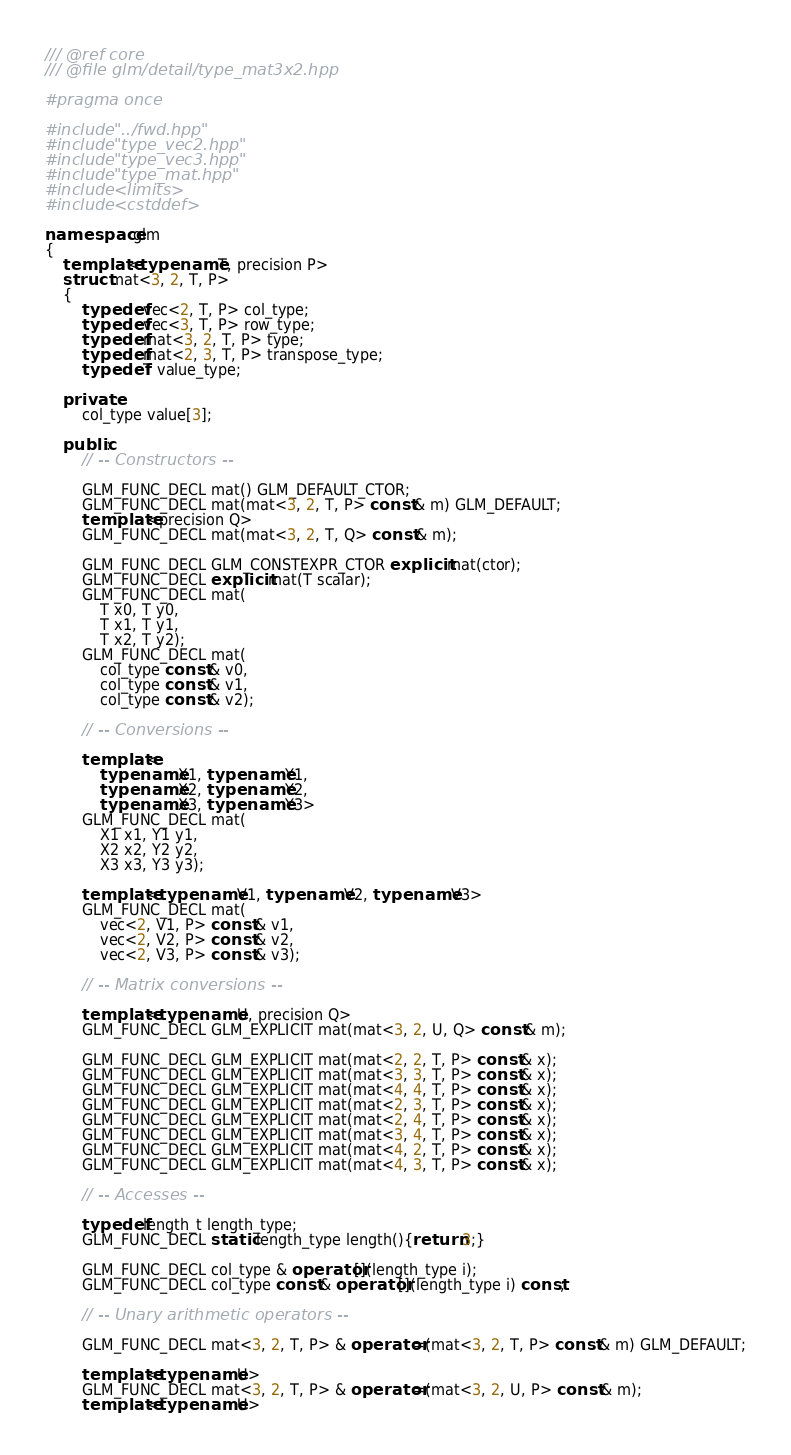<code> <loc_0><loc_0><loc_500><loc_500><_C++_>/// @ref core
/// @file glm/detail/type_mat3x2.hpp

#pragma once

#include "../fwd.hpp"
#include "type_vec2.hpp"
#include "type_vec3.hpp"
#include "type_mat.hpp"
#include <limits>
#include <cstddef>

namespace glm
{
	template<typename T, precision P>
	struct mat<3, 2, T, P>
	{
		typedef vec<2, T, P> col_type;
		typedef vec<3, T, P> row_type;
		typedef mat<3, 2, T, P> type;
		typedef mat<2, 3, T, P> transpose_type;
		typedef T value_type;

	private:
		col_type value[3];

	public:
		// -- Constructors --

		GLM_FUNC_DECL mat() GLM_DEFAULT_CTOR;
		GLM_FUNC_DECL mat(mat<3, 2, T, P> const & m) GLM_DEFAULT;
		template<precision Q>
		GLM_FUNC_DECL mat(mat<3, 2, T, Q> const & m);

		GLM_FUNC_DECL GLM_CONSTEXPR_CTOR explicit mat(ctor);
		GLM_FUNC_DECL explicit mat(T scalar);
		GLM_FUNC_DECL mat(
			T x0, T y0,
			T x1, T y1,
			T x2, T y2);
		GLM_FUNC_DECL mat(
			col_type const & v0,
			col_type const & v1,
			col_type const & v2);

		// -- Conversions --

		template<
			typename X1, typename Y1,
			typename X2, typename Y2,
			typename X3, typename Y3>
		GLM_FUNC_DECL mat(
			X1 x1, Y1 y1,
			X2 x2, Y2 y2,
			X3 x3, Y3 y3);

		template<typename V1, typename V2, typename V3>
		GLM_FUNC_DECL mat(
			vec<2, V1, P> const & v1,
			vec<2, V2, P> const & v2,
			vec<2, V3, P> const & v3);

		// -- Matrix conversions --

		template<typename U, precision Q>
		GLM_FUNC_DECL GLM_EXPLICIT mat(mat<3, 2, U, Q> const & m);

		GLM_FUNC_DECL GLM_EXPLICIT mat(mat<2, 2, T, P> const & x);
		GLM_FUNC_DECL GLM_EXPLICIT mat(mat<3, 3, T, P> const & x);
		GLM_FUNC_DECL GLM_EXPLICIT mat(mat<4, 4, T, P> const & x);
		GLM_FUNC_DECL GLM_EXPLICIT mat(mat<2, 3, T, P> const & x);
		GLM_FUNC_DECL GLM_EXPLICIT mat(mat<2, 4, T, P> const & x);
		GLM_FUNC_DECL GLM_EXPLICIT mat(mat<3, 4, T, P> const & x);
		GLM_FUNC_DECL GLM_EXPLICIT mat(mat<4, 2, T, P> const & x);
		GLM_FUNC_DECL GLM_EXPLICIT mat(mat<4, 3, T, P> const & x);

		// -- Accesses --

		typedef length_t length_type;
		GLM_FUNC_DECL static length_type length(){return 3;}

		GLM_FUNC_DECL col_type & operator[](length_type i);
		GLM_FUNC_DECL col_type const & operator[](length_type i) const;

		// -- Unary arithmetic operators --

		GLM_FUNC_DECL mat<3, 2, T, P> & operator=(mat<3, 2, T, P> const & m) GLM_DEFAULT;

		template<typename U>
		GLM_FUNC_DECL mat<3, 2, T, P> & operator=(mat<3, 2, U, P> const & m);
		template<typename U></code> 